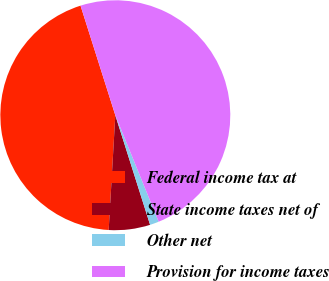<chart> <loc_0><loc_0><loc_500><loc_500><pie_chart><fcel>Federal income tax at<fcel>State income taxes net of<fcel>Other net<fcel>Provision for income taxes<nl><fcel>44.19%<fcel>5.81%<fcel>1.26%<fcel>48.74%<nl></chart> 